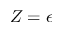Convert formula to latex. <formula><loc_0><loc_0><loc_500><loc_500>Z = \epsilon</formula> 